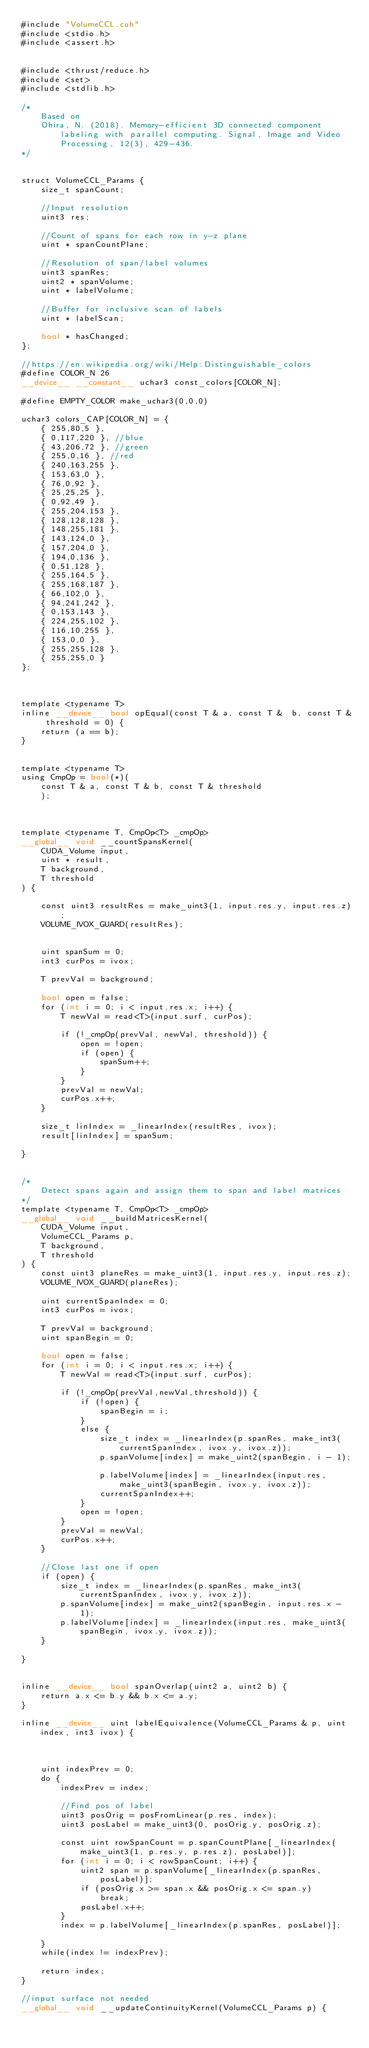Convert code to text. <code><loc_0><loc_0><loc_500><loc_500><_Cuda_>#include "VolumeCCL.cuh"
#include <stdio.h>
#include <assert.h>


#include <thrust/reduce.h>
#include <set>
#include <stdlib.h>

/*
	Based on
	Ohira, N. (2018). Memory-efficient 3D connected component labeling with parallel computing. Signal, Image and Video Processing, 12(3), 429-436.
*/


struct VolumeCCL_Params {
	size_t spanCount;

	//Input resolution	
	uint3 res;

	//Count of spans for each row in y-z plane
	uint * spanCountPlane;

	//Resolution of span/label volumes
	uint3 spanRes;	
	uint2 * spanVolume;
	uint * labelVolume;
	
	//Buffer for inclusive scan of labels
	uint * labelScan;

	bool * hasChanged;
};

//https://en.wikipedia.org/wiki/Help:Distinguishable_colors
#define COLOR_N 26
__device__ __constant__ uchar3 const_colors[COLOR_N];

#define EMPTY_COLOR make_uchar3(0,0,0)

uchar3 colors_CAP[COLOR_N] = {	
	{ 255,80,5 },
	{ 0,117,220 }, //blue
	{ 43,206,72 }, //green
	{ 255,0,16 }, //red
	{ 240,163,255 },	
	{ 153,63,0 },
	{ 76,0,92 },
	{ 25,25,25 },
	{ 0,92,49 },	
	{ 255,204,153 },
	{ 128,128,128 },
	{ 148,255,181 },
	{ 143,124,0 },
	{ 157,204,0 },
	{ 194,0,136 },
	{ 0,51,128 },
	{ 255,164,5 },
	{ 255,168,187 },
	{ 66,102,0 },	
	{ 94,241,242 },
	{ 0,153,143 },
	{ 224,255,102 },
	{ 116,10,255 },
	{ 153,0,0 },
	{ 255,255,128 },
	{ 255,255,0 }	
};



template <typename T>
inline __device__ bool opEqual(const T & a, const T &  b, const T & threshold = 0) {
	return (a == b);
}


template <typename T>
using CmpOp = bool(*)(
	const T & a, const T & b, const T & threshold
	);



template <typename T, CmpOp<T> _cmpOp>
__global__ void __countSpansKernel(
	CUDA_Volume input, 
	uint * result,
	T background,
	T threshold
) {

	const uint3 resultRes = make_uint3(1, input.res.y, input.res.z);
	VOLUME_IVOX_GUARD(resultRes);
	

	uint spanSum = 0;
	int3 curPos = ivox;

	T prevVal = background;

	bool open = false;
	for (int i = 0; i < input.res.x; i++) {
		T newVal = read<T>(input.surf, curPos);
		
		if (!_cmpOp(prevVal, newVal, threshold)) {
			open = !open;
			if (open) {
				spanSum++;				
			}
		}		
		prevVal = newVal;
		curPos.x++;
	}

	size_t linIndex = _linearIndex(resultRes, ivox);
	result[linIndex] = spanSum;

}


/*
	Detect spans again and assign them to span and label matrices
*/
template <typename T, CmpOp<T> _cmpOp>
__global__ void __buildMatricesKernel(
	CUDA_Volume input,
	VolumeCCL_Params p,
	T background,
	T threshold
) {
	const uint3 planeRes = make_uint3(1, input.res.y, input.res.z);
	VOLUME_IVOX_GUARD(planeRes);	

	uint currentSpanIndex = 0;
	int3 curPos = ivox;

	T prevVal = background;
	uint spanBegin = 0;

	bool open = false;
	for (int i = 0; i < input.res.x; i++) {
		T newVal = read<T>(input.surf, curPos);

		if (!_cmpOp(prevVal,newVal,threshold)) {
			if (!open) {				
				spanBegin = i;								
			}
			else {		
				size_t index = _linearIndex(p.spanRes, make_int3(currentSpanIndex, ivox.y, ivox.z));
				p.spanVolume[index] = make_uint2(spanBegin, i - 1);				
				p.labelVolume[index] = _linearIndex(input.res, make_uint3(spanBegin, ivox.y, ivox.z));
				currentSpanIndex++;
			}
			open = !open;
		}
		prevVal = newVal;
		curPos.x++;
	}

	//Close last one if open
	if (open) {
		size_t index = _linearIndex(p.spanRes, make_int3(currentSpanIndex, ivox.y, ivox.z));
		p.spanVolume[index] = make_uint2(spanBegin, input.res.x - 1);
		p.labelVolume[index] = _linearIndex(input.res, make_uint3(spanBegin, ivox.y, ivox.z));
	}

}


inline __device__ bool spanOverlap(uint2 a, uint2 b) {
	return a.x <= b.y && b.x <= a.y;
}

inline __device__ uint labelEquivalence(VolumeCCL_Params & p, uint index, int3 ivox) {

	
	
	uint indexPrev = 0;	
	do {
		indexPrev = index;	

		//Find pos of label
		uint3 posOrig = posFromLinear(p.res, index);
		uint3 posLabel = make_uint3(0, posOrig.y, posOrig.z);

		const uint rowSpanCount = p.spanCountPlane[_linearIndex(make_uint3(1, p.res.y, p.res.z), posLabel)];
		for (int i = 0; i < rowSpanCount; i++) {			
			uint2 span = p.spanVolume[_linearIndex(p.spanRes, posLabel)];
			if (posOrig.x >= span.x && posOrig.x <= span.y)
				break;		
			posLabel.x++;
		}
		index = p.labelVolume[_linearIndex(p.spanRes, posLabel)];
		
	}
	while(index != indexPrev);

	return index;
}

//input surface not needed
__global__ void __updateContinuityKernel(VolumeCCL_Params p) {</code> 